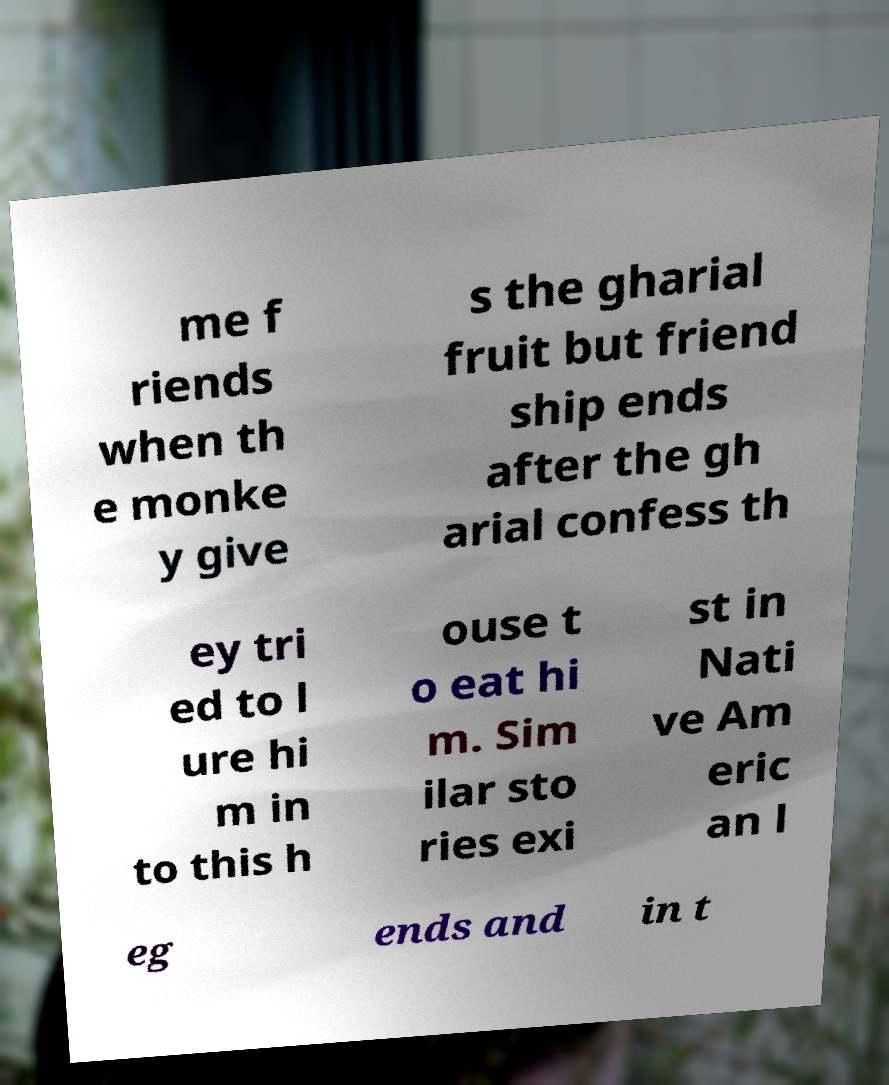For documentation purposes, I need the text within this image transcribed. Could you provide that? me f riends when th e monke y give s the gharial fruit but friend ship ends after the gh arial confess th ey tri ed to l ure hi m in to this h ouse t o eat hi m. Sim ilar sto ries exi st in Nati ve Am eric an l eg ends and in t 